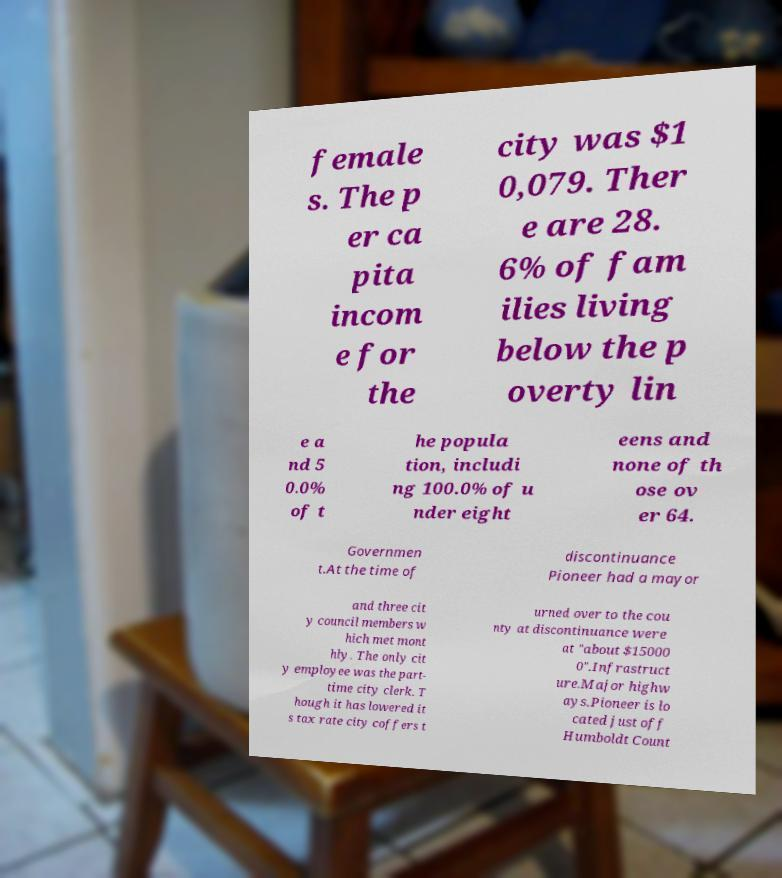Could you extract and type out the text from this image? female s. The p er ca pita incom e for the city was $1 0,079. Ther e are 28. 6% of fam ilies living below the p overty lin e a nd 5 0.0% of t he popula tion, includi ng 100.0% of u nder eight eens and none of th ose ov er 64. Governmen t.At the time of discontinuance Pioneer had a mayor and three cit y council members w hich met mont hly. The only cit y employee was the part- time city clerk. T hough it has lowered it s tax rate city coffers t urned over to the cou nty at discontinuance were at "about $15000 0".Infrastruct ure.Major highw ays.Pioneer is lo cated just off Humboldt Count 